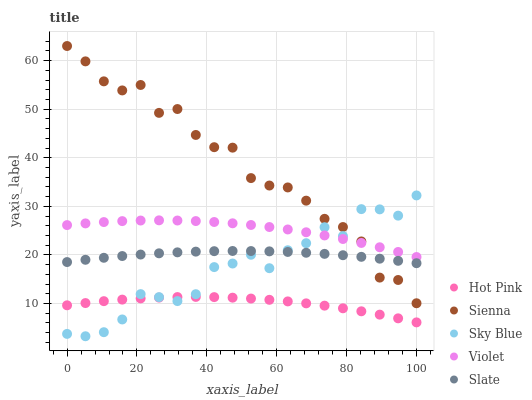Does Hot Pink have the minimum area under the curve?
Answer yes or no. Yes. Does Sienna have the maximum area under the curve?
Answer yes or no. Yes. Does Sky Blue have the minimum area under the curve?
Answer yes or no. No. Does Sky Blue have the maximum area under the curve?
Answer yes or no. No. Is Slate the smoothest?
Answer yes or no. Yes. Is Sienna the roughest?
Answer yes or no. Yes. Is Sky Blue the smoothest?
Answer yes or no. No. Is Sky Blue the roughest?
Answer yes or no. No. Does Sky Blue have the lowest value?
Answer yes or no. Yes. Does Slate have the lowest value?
Answer yes or no. No. Does Sienna have the highest value?
Answer yes or no. Yes. Does Sky Blue have the highest value?
Answer yes or no. No. Is Slate less than Violet?
Answer yes or no. Yes. Is Violet greater than Slate?
Answer yes or no. Yes. Does Sky Blue intersect Slate?
Answer yes or no. Yes. Is Sky Blue less than Slate?
Answer yes or no. No. Is Sky Blue greater than Slate?
Answer yes or no. No. Does Slate intersect Violet?
Answer yes or no. No. 